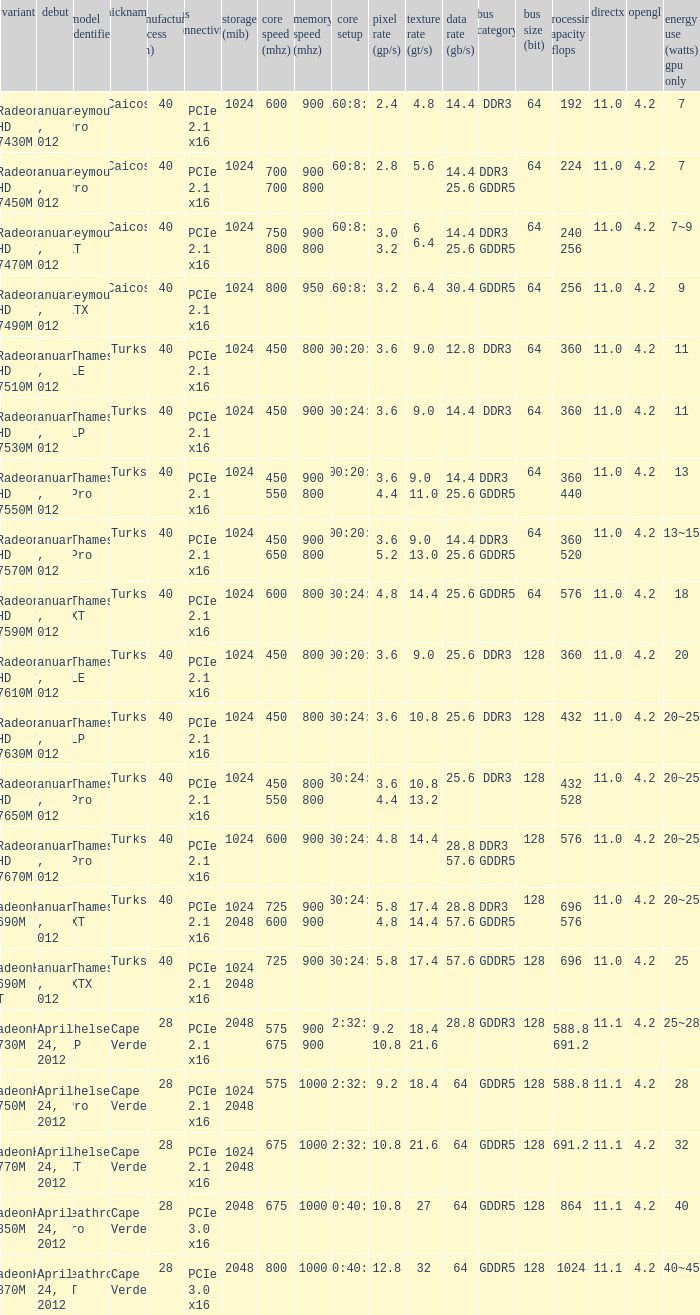What is the config core 1 of the model with a processing power GFLOPs of 432? 480:24:8. 